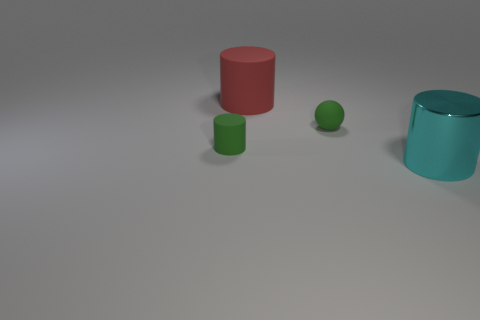Is there anything else that is made of the same material as the large cyan object?
Offer a very short reply. No. What color is the large rubber thing that is the same shape as the large shiny object?
Keep it short and to the point. Red. Do the matte cylinder on the left side of the red object and the sphere have the same size?
Your response must be concise. Yes. There is a rubber thing that is the same color as the small sphere; what shape is it?
Offer a very short reply. Cylinder. What number of small green objects are made of the same material as the big red cylinder?
Offer a terse response. 2. What is the material of the large object behind the green object in front of the green rubber thing on the right side of the green cylinder?
Give a very brief answer. Rubber. The big shiny object in front of the rubber object right of the large red thing is what color?
Offer a very short reply. Cyan. What is the color of the other thing that is the same size as the red matte thing?
Keep it short and to the point. Cyan. What number of tiny things are green shiny objects or cyan objects?
Your answer should be compact. 0. Is the number of large rubber cylinders on the left side of the green cylinder greater than the number of green cylinders that are in front of the large cyan cylinder?
Keep it short and to the point. No. 